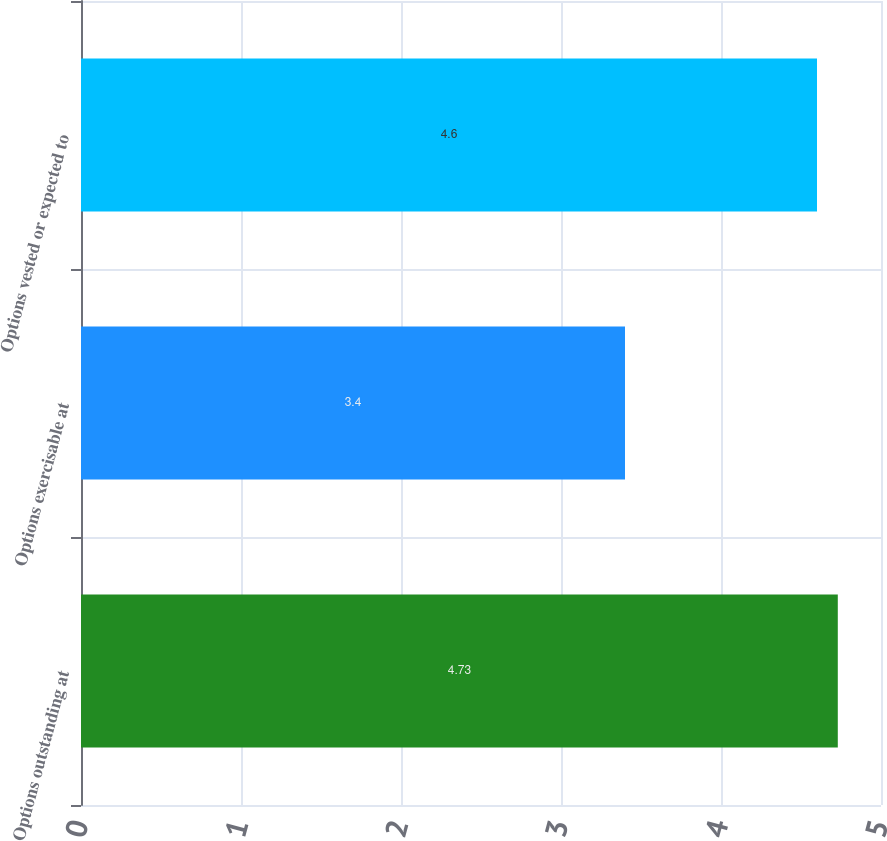Convert chart to OTSL. <chart><loc_0><loc_0><loc_500><loc_500><bar_chart><fcel>Options outstanding at<fcel>Options exercisable at<fcel>Options vested or expected to<nl><fcel>4.73<fcel>3.4<fcel>4.6<nl></chart> 